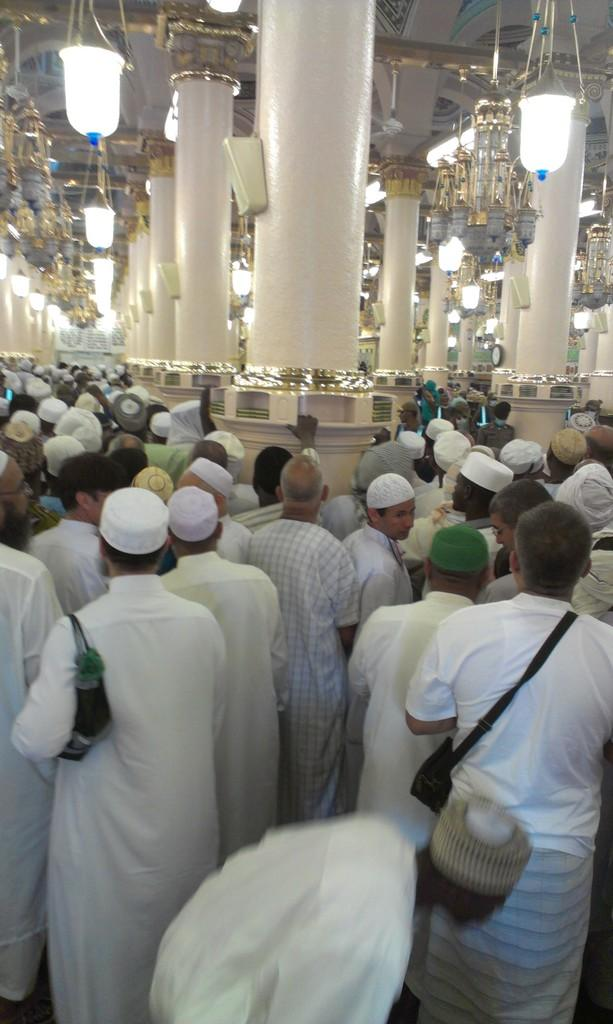How many people are present in the image? There are many people in the image. Where are the people located in the image? The people are standing in a hall. What can be seen hanging from the roof in the image? There are many lamps hanging from the roof in the image. Are there any icicles visible in the image? No, there are no icicles present in the image. Can you describe the stranger in the image? There is no stranger mentioned in the image; it only describes many people standing in a hall. 